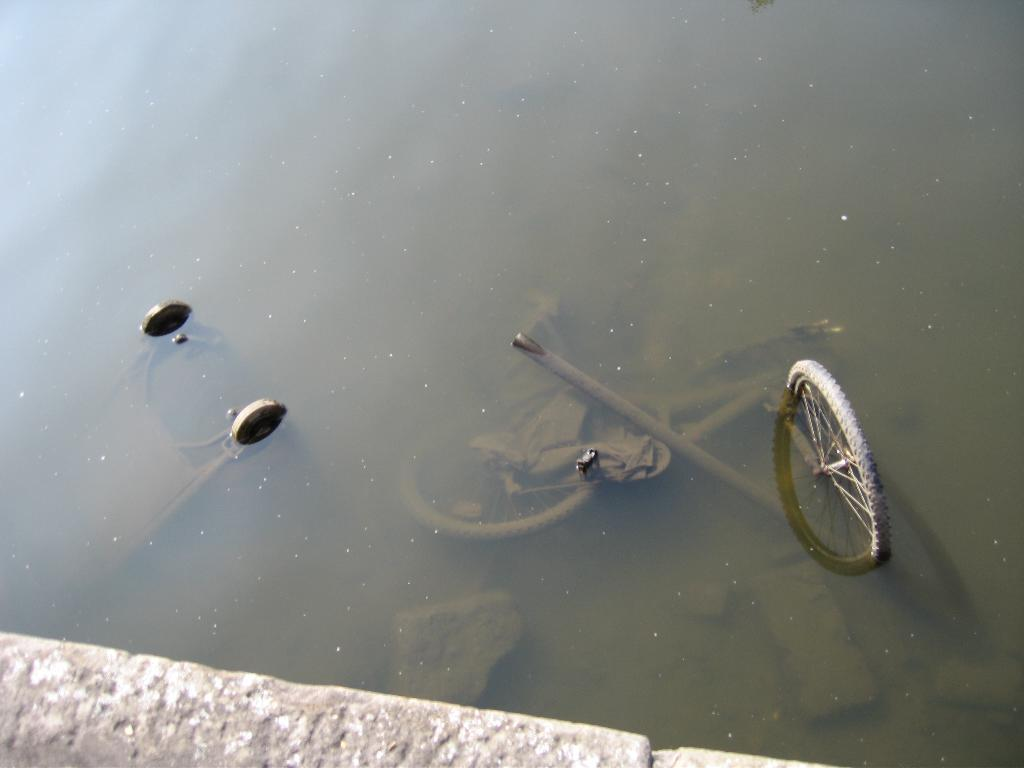What type of natural feature can be seen in the image? There is a river in the image. What is located in the river? A cycle is present in the river, along with other objects. Can you describe the bottom of the image? There might be a wall at the bottom of the image. What type of noise can be heard coming from the river in the image? There is no information about any noise in the image, so it cannot be determined from the image. 